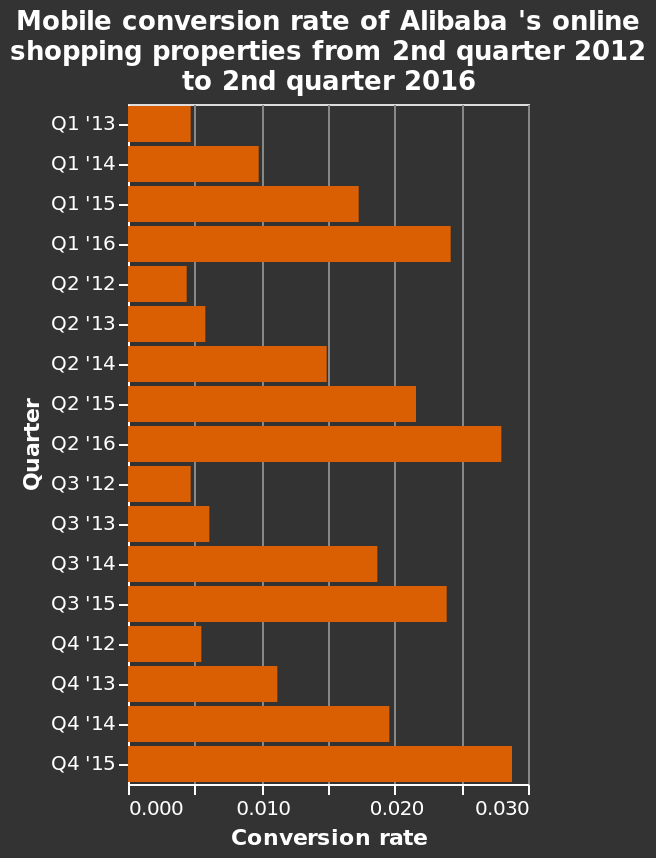<image>
What is being plotted on the y-axis of the chart? The y-axis of the chart represents the quarter. Is there a noticeable pattern in the graph?  Yes, there appears to be a rise and fall pattern. What time period does the chart cover? The chart covers the 2nd quarter of 2012 to the 2nd quarter of 2016. Offer a thorough analysis of the image. Quarters 15 and 16 are greatly higher than other months. There seems to be a rise and fall to the pattern of the graph. How would you describe the trend in quarters 15 and 16? The trend in these quarters shows a significant increase followed by a decrease. What is being plotted on the x-axis of the chart? The x-axis of the chart represents the conversion rate. 